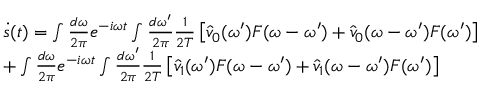Convert formula to latex. <formula><loc_0><loc_0><loc_500><loc_500>\begin{array} { r l } & { \dot { s } ( t ) = \int \frac { d \omega } { 2 \pi } e ^ { - i \omega t } \int \frac { d \omega ^ { \prime } } { 2 \pi } \frac { 1 } { 2 T } \left [ \hat { v } _ { 0 } ( \omega ^ { \prime } ) F ( \omega - \omega ^ { \prime } ) + \hat { v } _ { 0 } ( \omega - \omega ^ { \prime } ) F ( \omega ^ { \prime } ) \right ] } \\ & { + \int \frac { d \omega } { 2 \pi } e ^ { - i \omega t } \int \frac { d \omega ^ { \prime } } { 2 \pi } \frac { 1 } { 2 T } \left [ \hat { v } _ { 1 } ( \omega ^ { \prime } ) F ( \omega - \omega ^ { \prime } ) + \hat { v } _ { 1 } ( \omega - \omega ^ { \prime } ) F ( \omega ^ { \prime } ) \right ] } \end{array}</formula> 